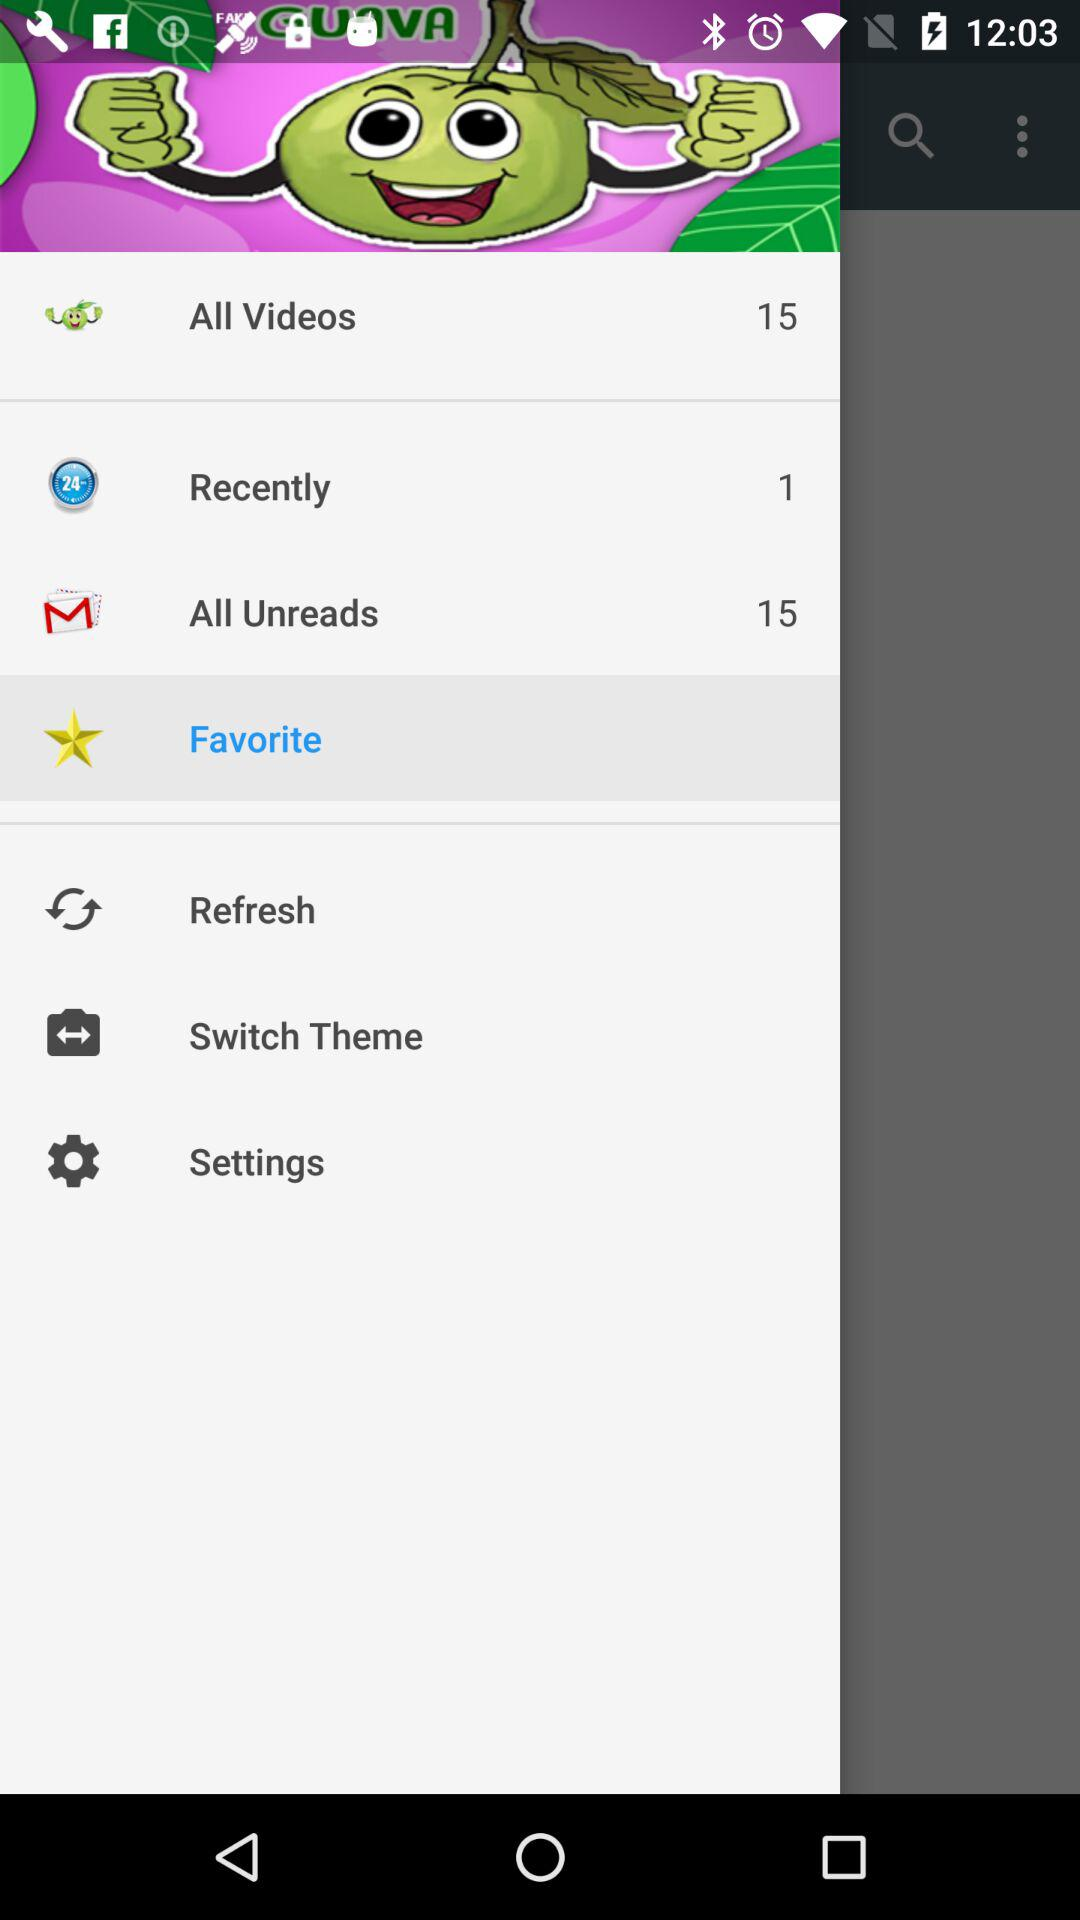Which item is selected? The selected item is "Favorite". 